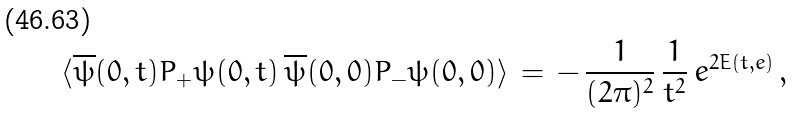<formula> <loc_0><loc_0><loc_500><loc_500>\langle \overline { \psi } ( 0 , t ) P _ { + } \psi ( 0 , t ) \, \overline { \psi } ( 0 , 0 ) P _ { - } \psi ( 0 , 0 ) \rangle \, = \, - \, \frac { 1 } { ( 2 \pi ) ^ { 2 } } \, \frac { 1 } { t ^ { 2 } } \, e ^ { 2 E ( t , e ) } \, ,</formula> 